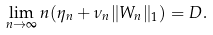<formula> <loc_0><loc_0><loc_500><loc_500>\lim _ { n \to \infty } n ( \eta _ { n } + \nu _ { n } \| W _ { n } \| _ { 1 } ) = D .</formula> 